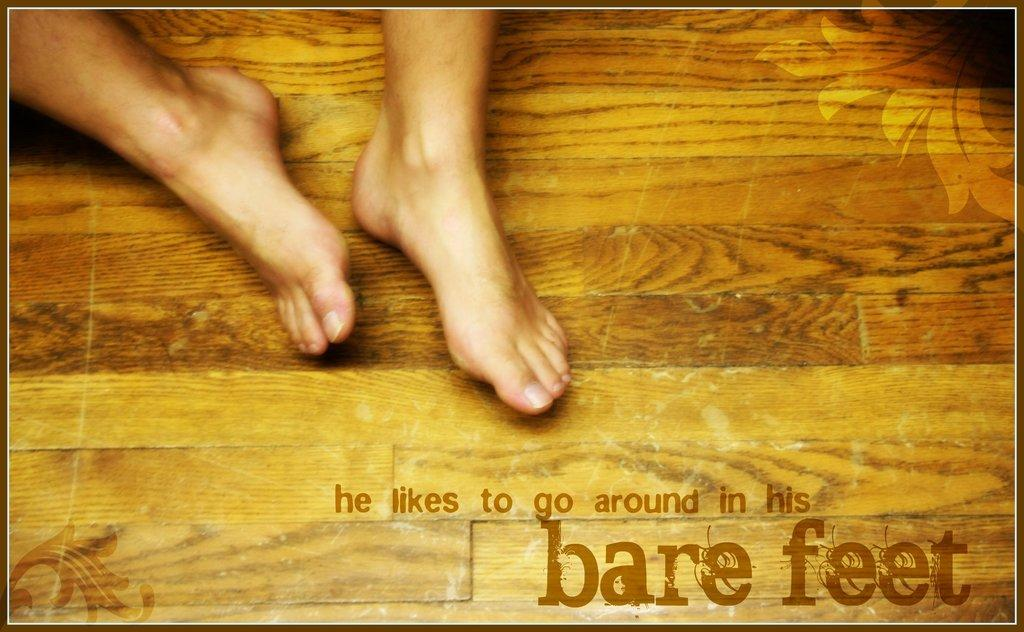<image>
Create a compact narrative representing the image presented. A sign that says "He likes to go around in his bare feet" with a photo of bare feet. 